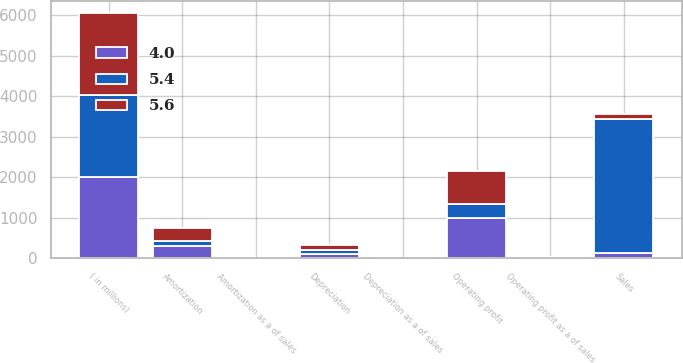<chart> <loc_0><loc_0><loc_500><loc_500><stacked_bar_chart><ecel><fcel>( in millions)<fcel>Sales<fcel>Operating profit<fcel>Depreciation<fcel>Amortization<fcel>Operating profit as a of sales<fcel>Depreciation as a of sales<fcel>Amortization as a of sales<nl><fcel>4<fcel>2017<fcel>122.9<fcel>1004.3<fcel>119<fcel>308.9<fcel>17.6<fcel>2.1<fcel>5.4<nl><fcel>5.6<fcel>2016<fcel>122.9<fcel>818.9<fcel>126.8<fcel>299.4<fcel>15.3<fcel>2.4<fcel>5.6<nl><fcel>5.4<fcel>2015<fcel>3314.6<fcel>329.2<fcel>77.3<fcel>132.8<fcel>9.9<fcel>2.3<fcel>4<nl></chart> 